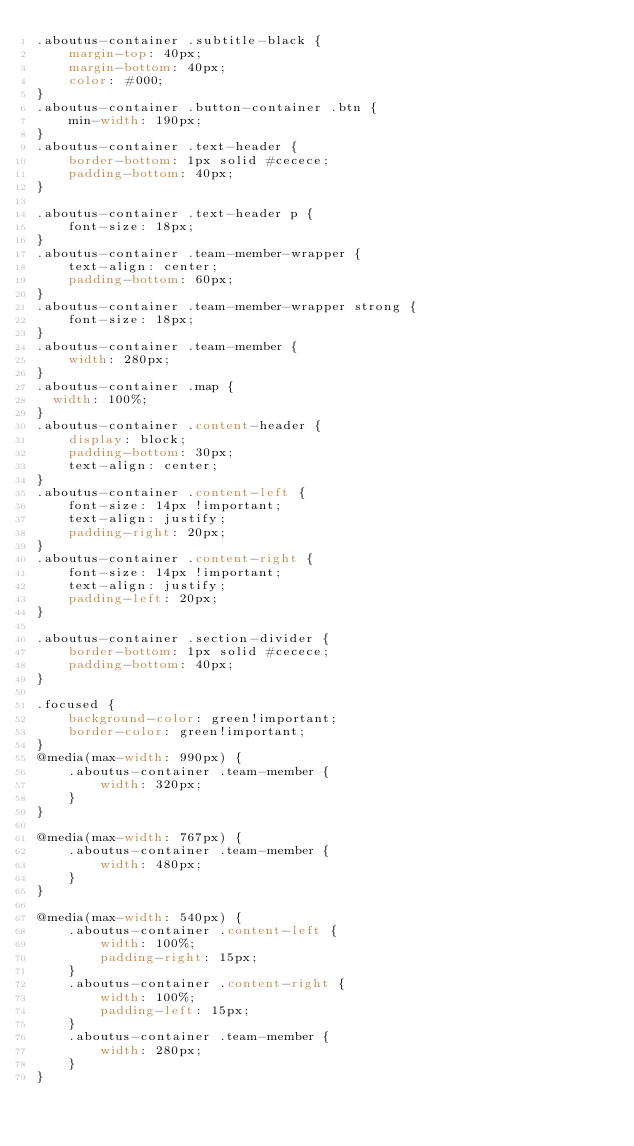Convert code to text. <code><loc_0><loc_0><loc_500><loc_500><_CSS_>.aboutus-container .subtitle-black {
    margin-top: 40px;
    margin-bottom: 40px;
    color: #000;
}
.aboutus-container .button-container .btn {
    min-width: 190px;
}
.aboutus-container .text-header {
    border-bottom: 1px solid #cecece;
    padding-bottom: 40px;
}

.aboutus-container .text-header p {
    font-size: 18px;
}
.aboutus-container .team-member-wrapper {
    text-align: center;
    padding-bottom: 60px;
}
.aboutus-container .team-member-wrapper strong {
    font-size: 18px;
}
.aboutus-container .team-member {
    width: 280px;
}
.aboutus-container .map {
	width: 100%;
}
.aboutus-container .content-header {
    display: block;
    padding-bottom: 30px;
    text-align: center;
}
.aboutus-container .content-left {
    font-size: 14px !important;
    text-align: justify;
    padding-right: 20px;
}
.aboutus-container .content-right {
    font-size: 14px !important;
    text-align: justify;
    padding-left: 20px;
}

.aboutus-container .section-divider {
    border-bottom: 1px solid #cecece;
    padding-bottom: 40px;
}

.focused {
    background-color: green!important;
    border-color: green!important;
}
@media(max-width: 990px) {
    .aboutus-container .team-member {
        width: 320px;
    }
}

@media(max-width: 767px) {
    .aboutus-container .team-member {
        width: 480px;
    }
}

@media(max-width: 540px) {
    .aboutus-container .content-left {
        width: 100%;
        padding-right: 15px;
    }
    .aboutus-container .content-right {
        width: 100%;
        padding-left: 15px;
    }
    .aboutus-container .team-member {
        width: 280px;
    }
}
</code> 